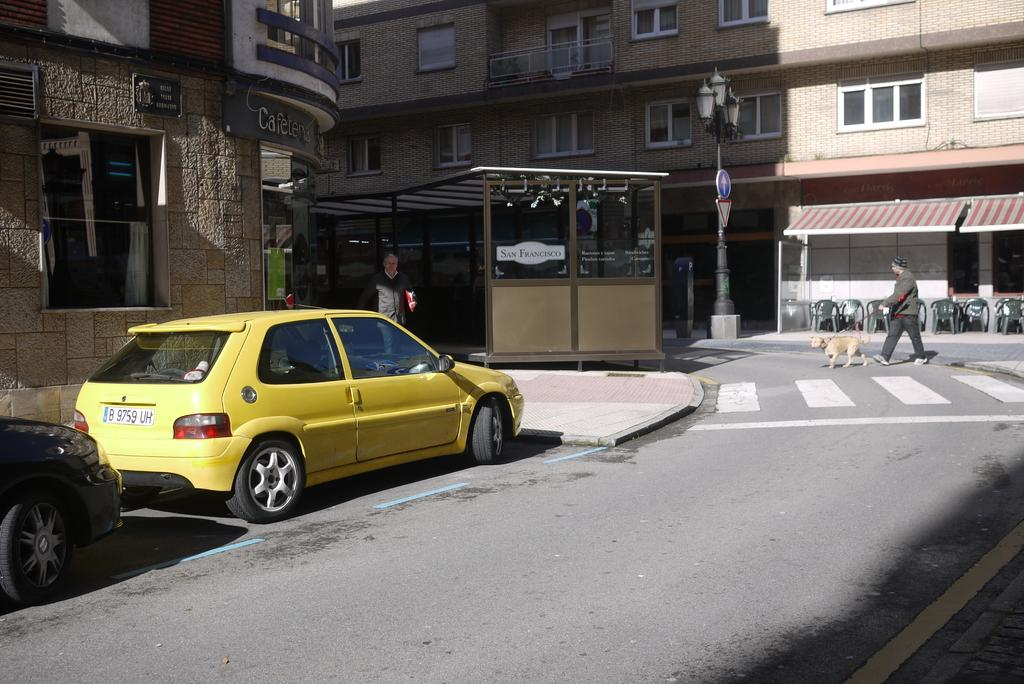What is the main feature of the image? There is a road in the image. What is happening on the road? There are two cars on the road. Are there any people or animals in the image? Yes, there is a person walking and a dog walking in the image. What can be seen in the background of the image? There are buildings visible in the image. Can you tell me what color the paint on the dog's fur is in the image? There is no mention of paint or any color alteration on the dog's fur in the image. 